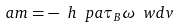Convert formula to latex. <formula><loc_0><loc_0><loc_500><loc_500>\ a m = - \ h \ p a \tau _ { B } \omega _ { \ } w d v</formula> 